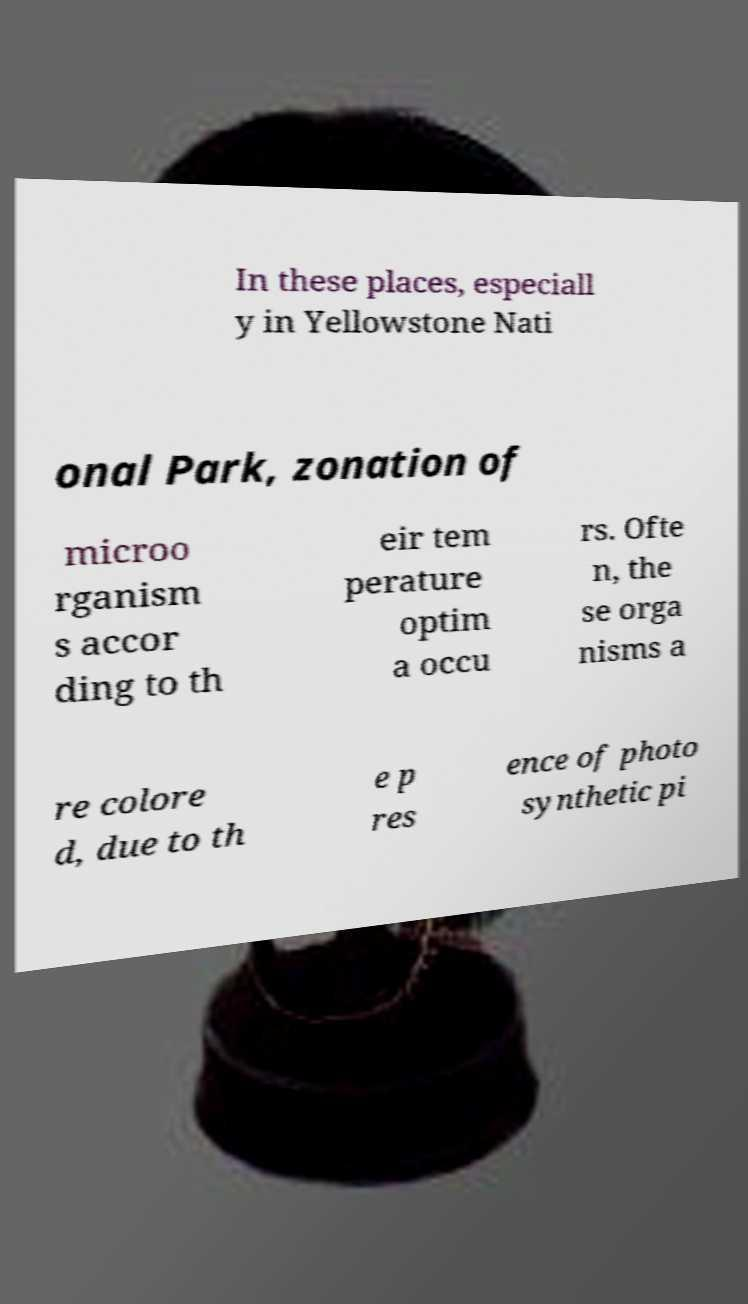What messages or text are displayed in this image? I need them in a readable, typed format. In these places, especiall y in Yellowstone Nati onal Park, zonation of microo rganism s accor ding to th eir tem perature optim a occu rs. Ofte n, the se orga nisms a re colore d, due to th e p res ence of photo synthetic pi 